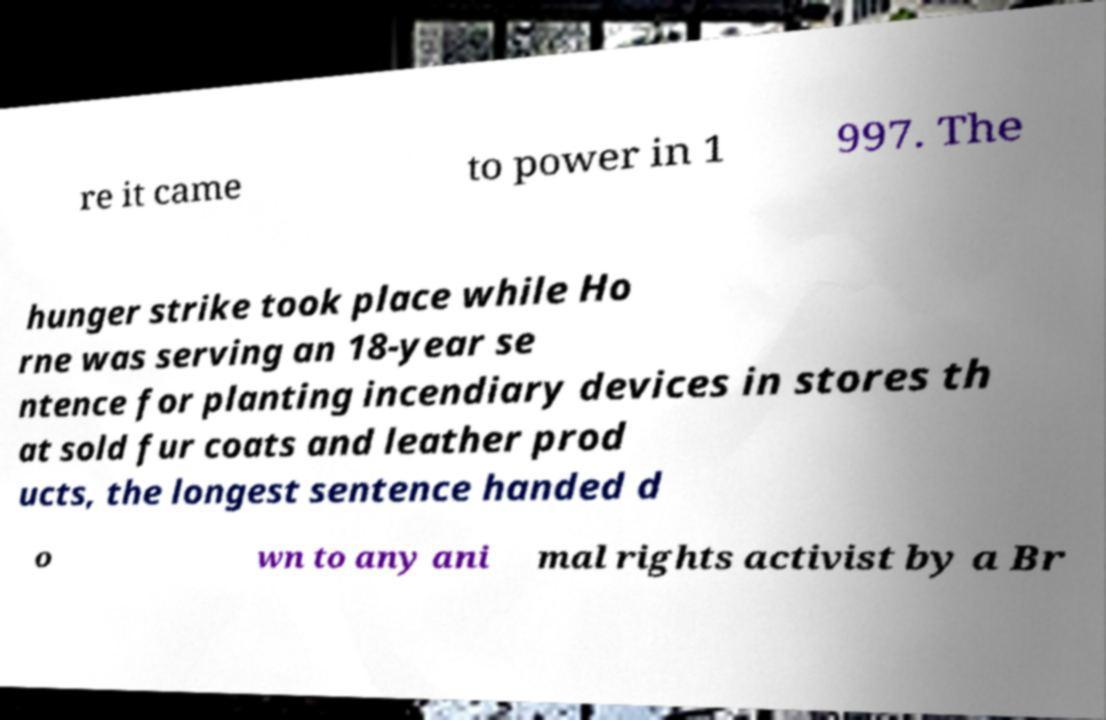Please read and relay the text visible in this image. What does it say? re it came to power in 1 997. The hunger strike took place while Ho rne was serving an 18-year se ntence for planting incendiary devices in stores th at sold fur coats and leather prod ucts, the longest sentence handed d o wn to any ani mal rights activist by a Br 